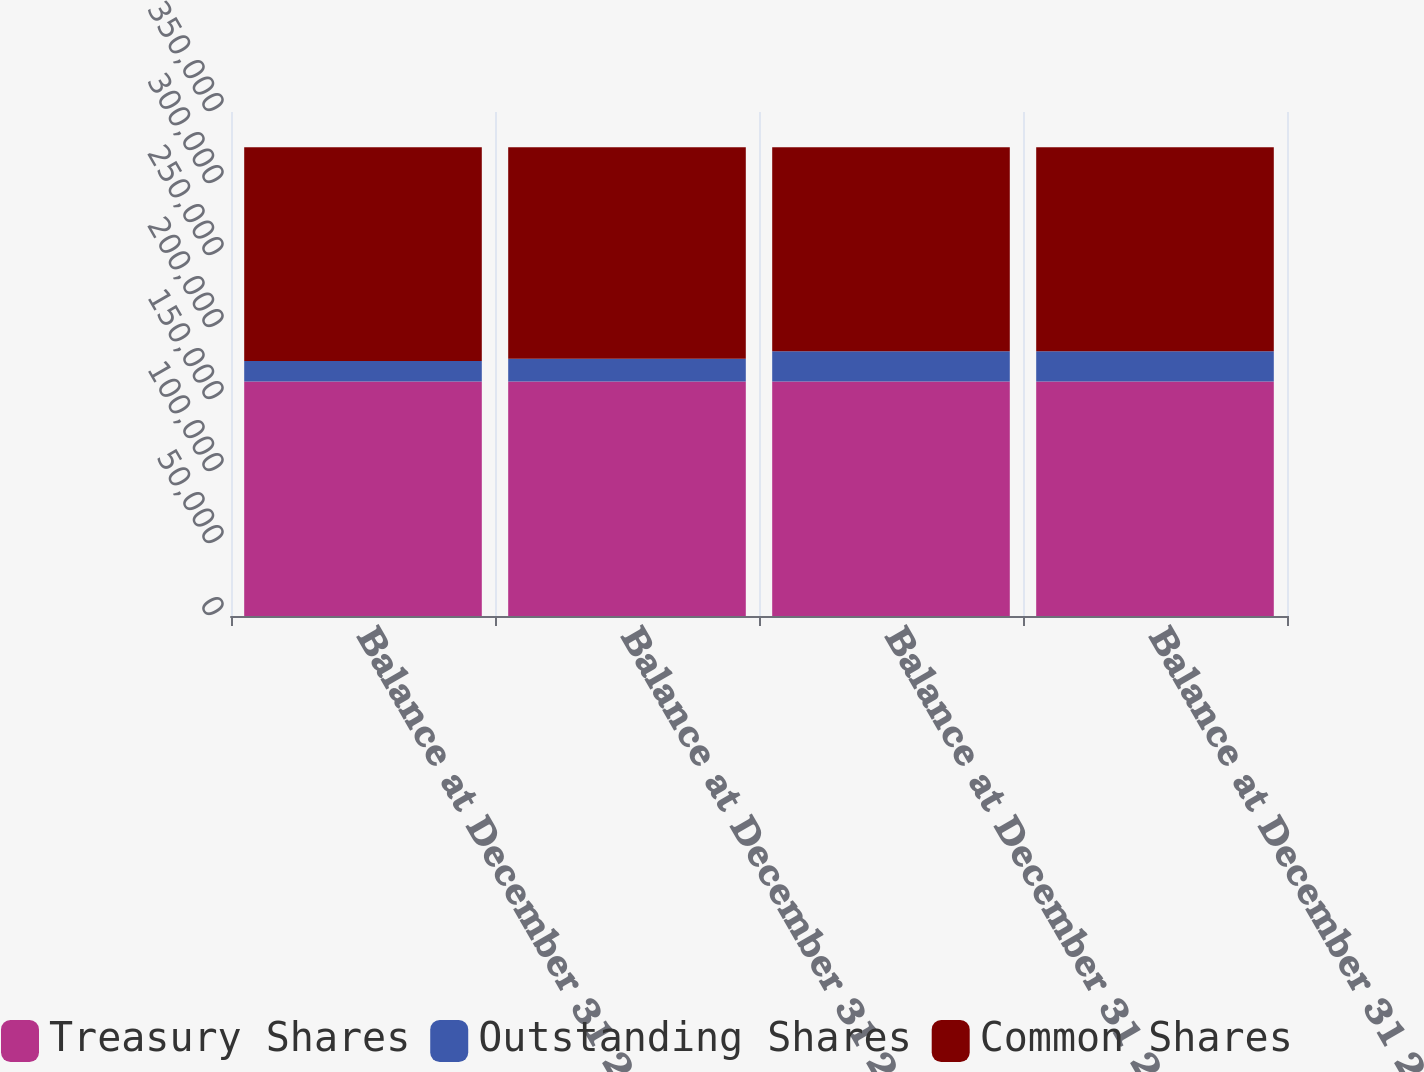Convert chart. <chart><loc_0><loc_0><loc_500><loc_500><stacked_bar_chart><ecel><fcel>Balance at December 31 2008<fcel>Balance at December 31 2009<fcel>Balance at December 31 2010<fcel>Balance at December 31 2011<nl><fcel>Treasury Shares<fcel>162776<fcel>162776<fcel>162776<fcel>162776<nl><fcel>Outstanding Shares<fcel>14248<fcel>15815<fcel>21041<fcel>21144<nl><fcel>Common Shares<fcel>148528<fcel>146961<fcel>141735<fcel>141632<nl></chart> 